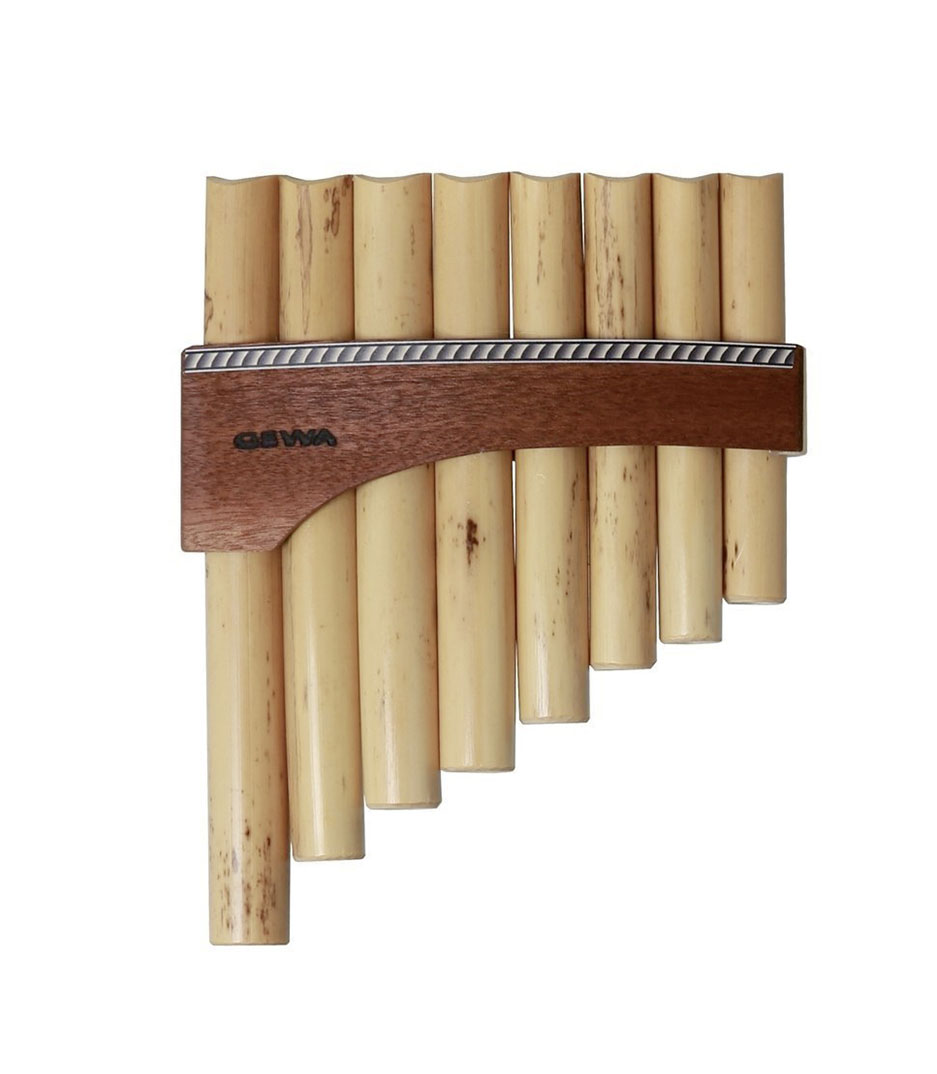Can you explain the cultural significance of the pan flute and where it is commonly used? The pan flute, also known as the panpipes, holds significant cultural value in various regions, particularly in South American Andean music. It's a key instrument in traditional music ensembles, used to convey stories and emotions in folk music. The unique, airy sound of the pan flute is closely associated with the pastoral and serene landscapes from which it originated. In modern times, its enchanting sound has been incorporated into various genres of music worldwide, symbolizing peace and nature. 